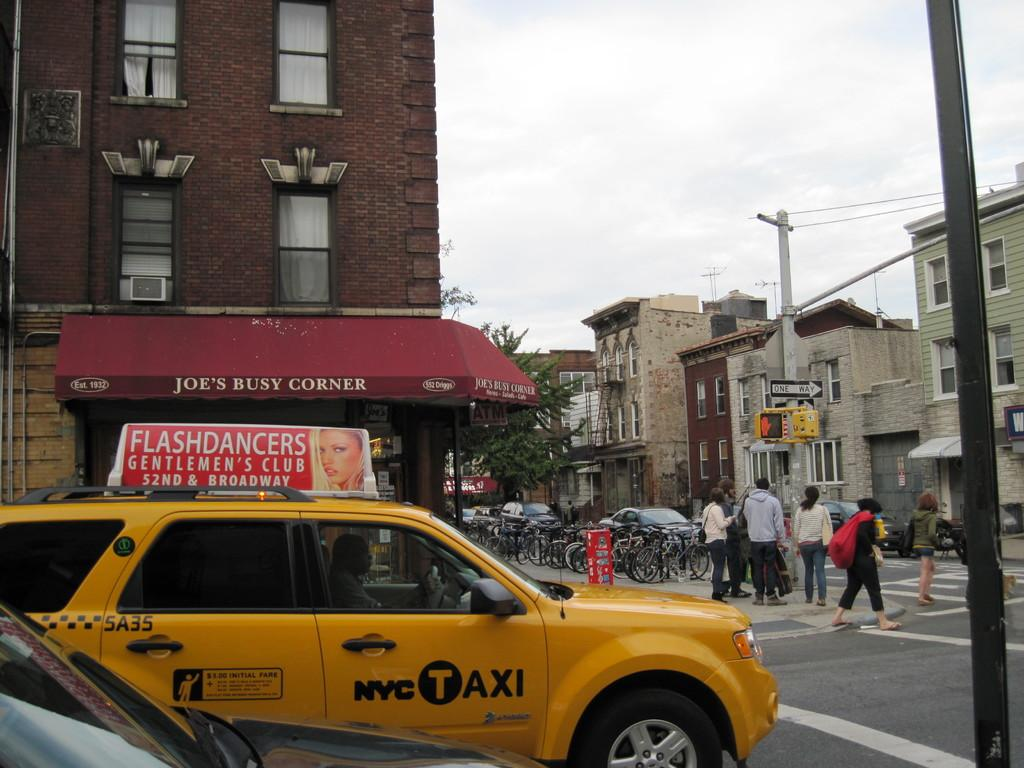<image>
Give a short and clear explanation of the subsequent image. A taxi is passing the store Joe's Busy Corner. 